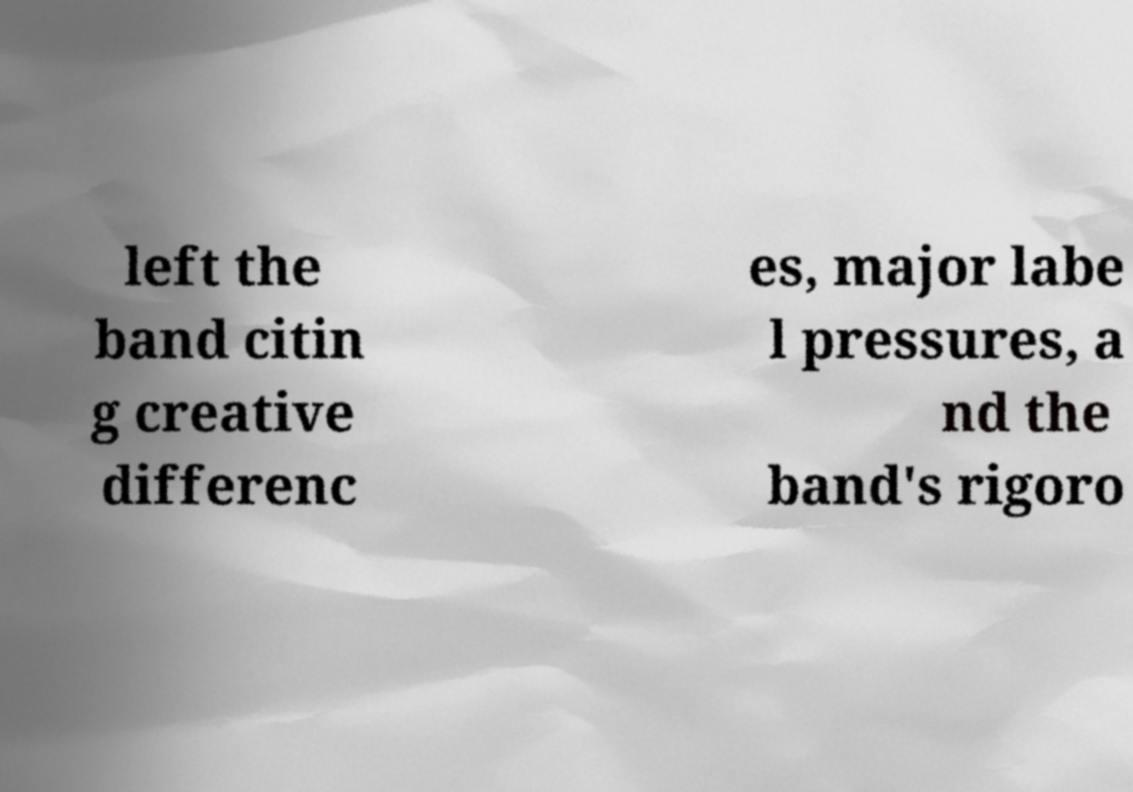For documentation purposes, I need the text within this image transcribed. Could you provide that? left the band citin g creative differenc es, major labe l pressures, a nd the band's rigoro 